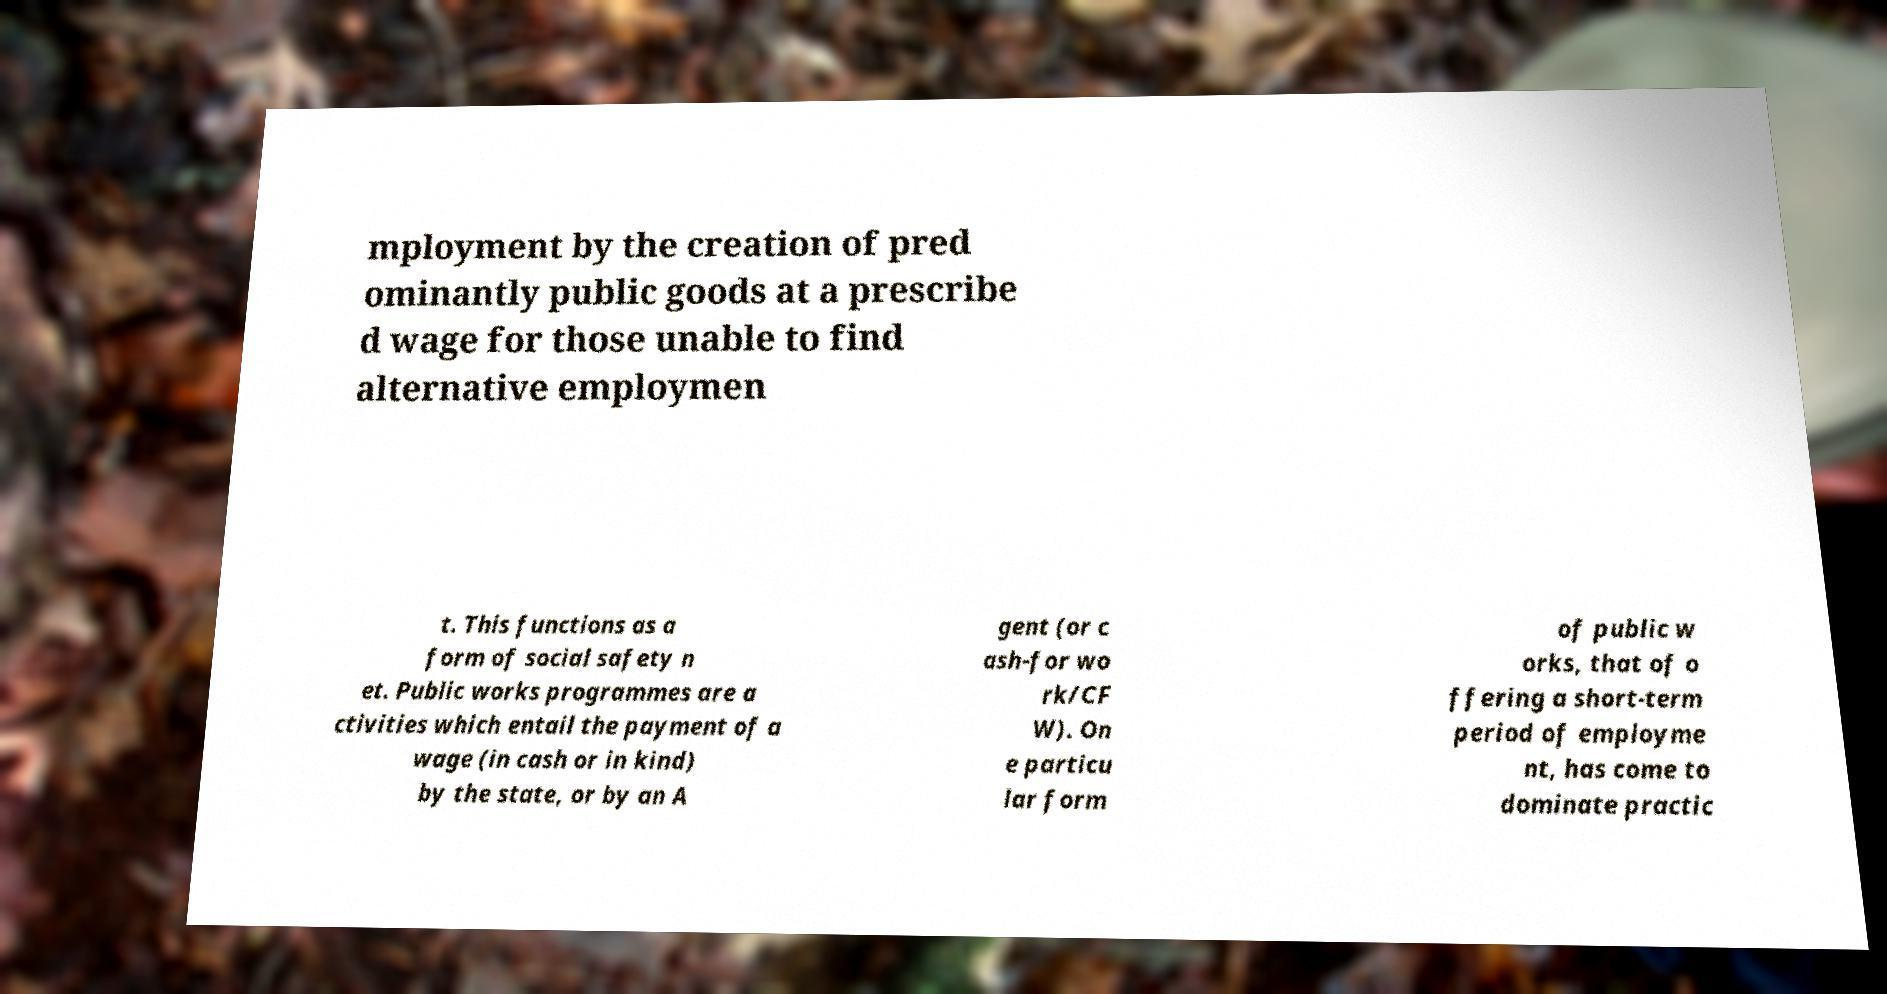There's text embedded in this image that I need extracted. Can you transcribe it verbatim? mployment by the creation of pred ominantly public goods at a prescribe d wage for those unable to find alternative employmen t. This functions as a form of social safety n et. Public works programmes are a ctivities which entail the payment of a wage (in cash or in kind) by the state, or by an A gent (or c ash-for wo rk/CF W). On e particu lar form of public w orks, that of o ffering a short-term period of employme nt, has come to dominate practic 